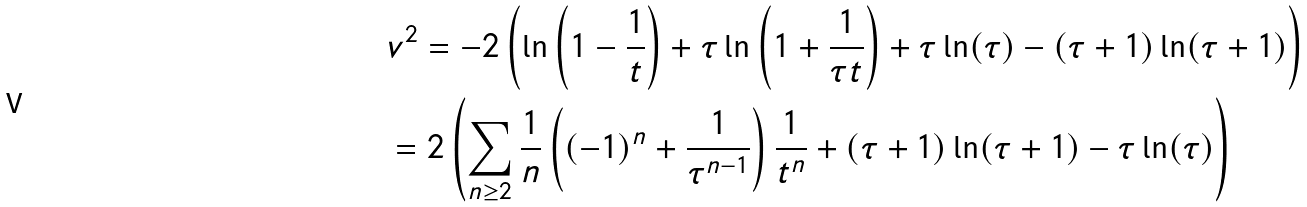<formula> <loc_0><loc_0><loc_500><loc_500>& v ^ { 2 } = - 2 \left ( \ln \left ( 1 - \frac { 1 } { t } \right ) + \tau \ln \left ( 1 + \frac { 1 } { \tau t } \right ) + \tau \ln ( \tau ) - ( \tau + 1 ) \ln ( \tau + 1 ) \right ) \\ & = 2 \left ( \sum _ { n \geq 2 } \frac { 1 } { n } \left ( ( - 1 ) ^ { n } + \frac { 1 } { \tau ^ { n - 1 } } \right ) \frac { 1 } { t ^ { n } } + ( \tau + 1 ) \ln ( \tau + 1 ) - \tau \ln ( \tau ) \right )</formula> 